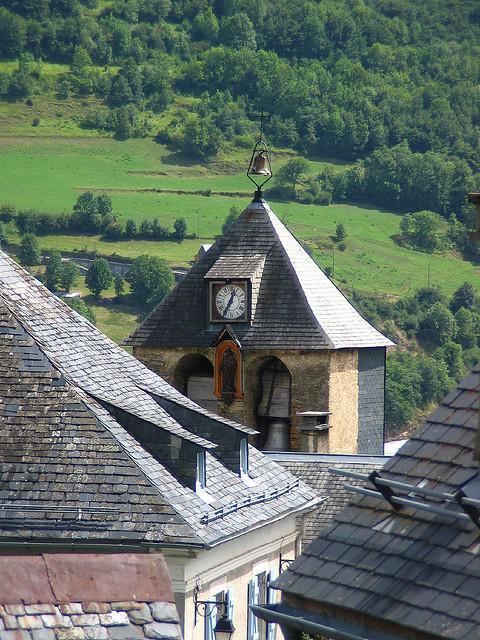How many bike on this image?
Give a very brief answer. 0. 